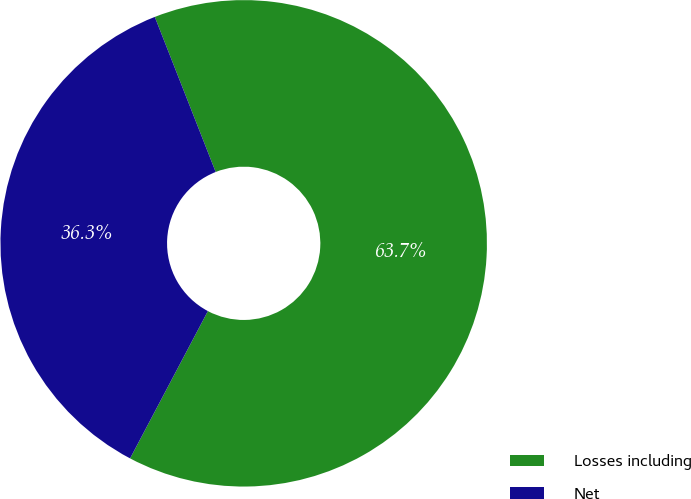<chart> <loc_0><loc_0><loc_500><loc_500><pie_chart><fcel>Losses including<fcel>Net<nl><fcel>63.69%<fcel>36.31%<nl></chart> 